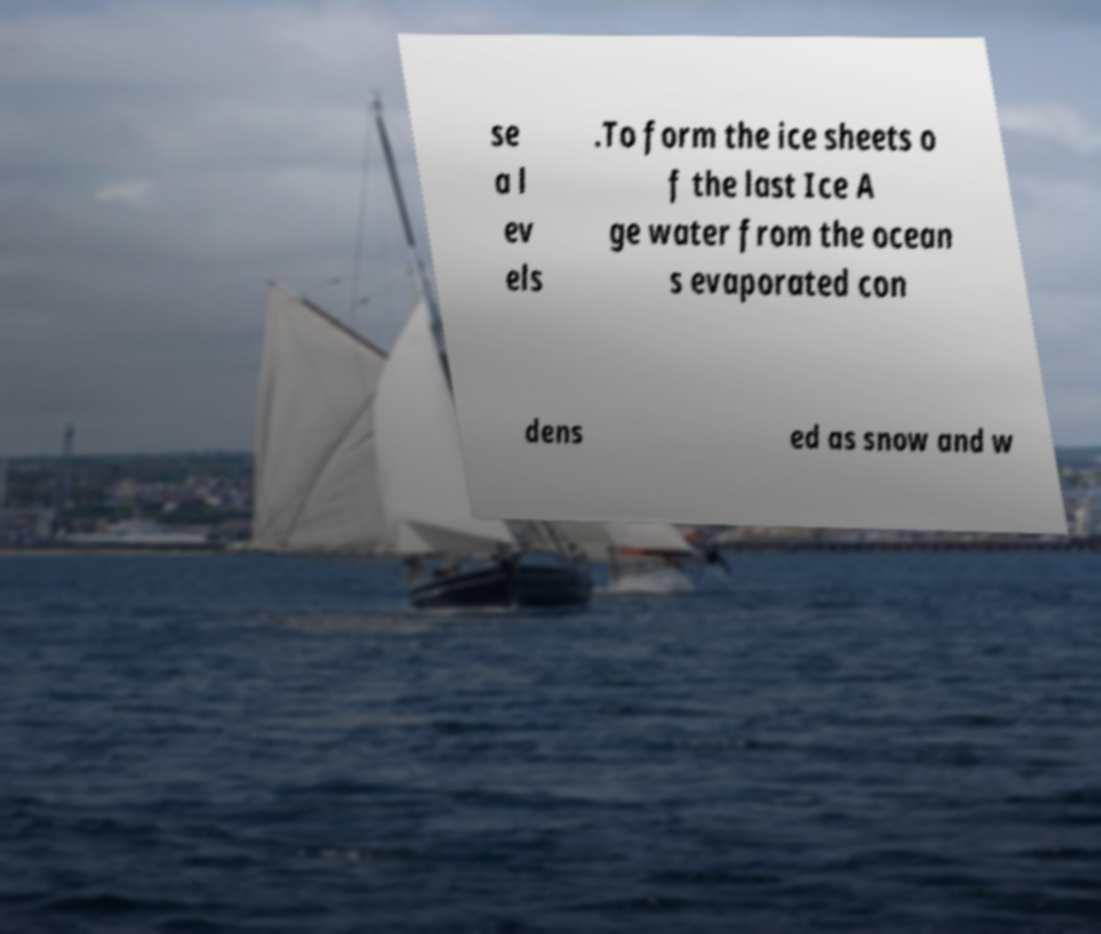Can you read and provide the text displayed in the image?This photo seems to have some interesting text. Can you extract and type it out for me? se a l ev els .To form the ice sheets o f the last Ice A ge water from the ocean s evaporated con dens ed as snow and w 